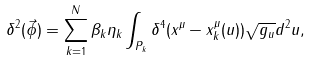<formula> <loc_0><loc_0><loc_500><loc_500>\delta ^ { 2 } ( \vec { \phi } ) = \sum _ { k = 1 } ^ { N } \beta _ { k } \eta _ { k } \int _ { P _ { k } } \delta ^ { 4 } ( x ^ { \mu } - x _ { k } ^ { \mu } ( u ) ) \sqrt { g _ { u } } d ^ { 2 } u ,</formula> 